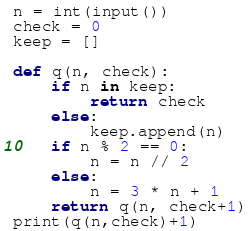Convert code to text. <code><loc_0><loc_0><loc_500><loc_500><_Python_>n = int(input())
check = 0
keep = []

def q(n, check):
    if n in keep:
        return check
    else:
        keep.append(n)
    if n % 2 == 0:
        n = n // 2
    else:
        n = 3 * n + 1
    return q(n, check+1)
print(q(n,check)+1)
</code> 